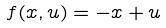<formula> <loc_0><loc_0><loc_500><loc_500>f ( x , u ) = - x + u</formula> 